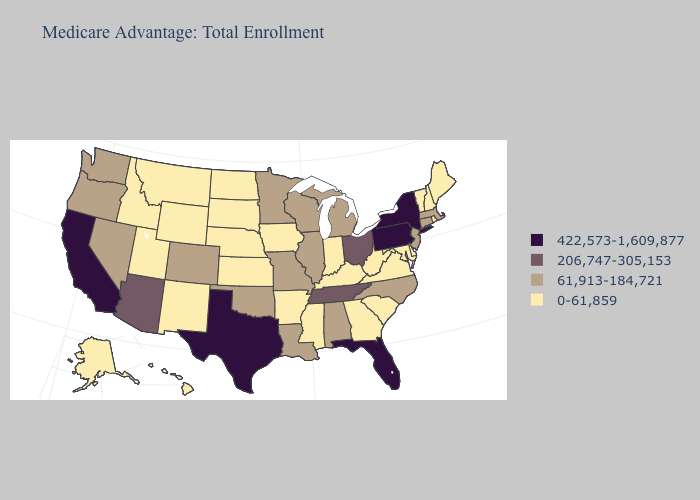Does Wyoming have the same value as Pennsylvania?
Quick response, please. No. Which states have the lowest value in the Northeast?
Concise answer only. Maine, New Hampshire, Rhode Island, Vermont. What is the value of Mississippi?
Short answer required. 0-61,859. Does New York have the highest value in the Northeast?
Concise answer only. Yes. What is the highest value in the USA?
Give a very brief answer. 422,573-1,609,877. What is the value of Nebraska?
Keep it brief. 0-61,859. Among the states that border Arkansas , does Tennessee have the lowest value?
Be succinct. No. Name the states that have a value in the range 0-61,859?
Write a very short answer. Alaska, Arkansas, Delaware, Georgia, Hawaii, Iowa, Idaho, Indiana, Kansas, Kentucky, Maryland, Maine, Mississippi, Montana, North Dakota, Nebraska, New Hampshire, New Mexico, Rhode Island, South Carolina, South Dakota, Utah, Virginia, Vermont, West Virginia, Wyoming. Which states hav the highest value in the Northeast?
Give a very brief answer. New York, Pennsylvania. Does the map have missing data?
Give a very brief answer. No. Does Maine have a higher value than West Virginia?
Answer briefly. No. What is the value of Connecticut?
Give a very brief answer. 61,913-184,721. What is the value of Minnesota?
Quick response, please. 61,913-184,721. What is the highest value in the West ?
Write a very short answer. 422,573-1,609,877. 